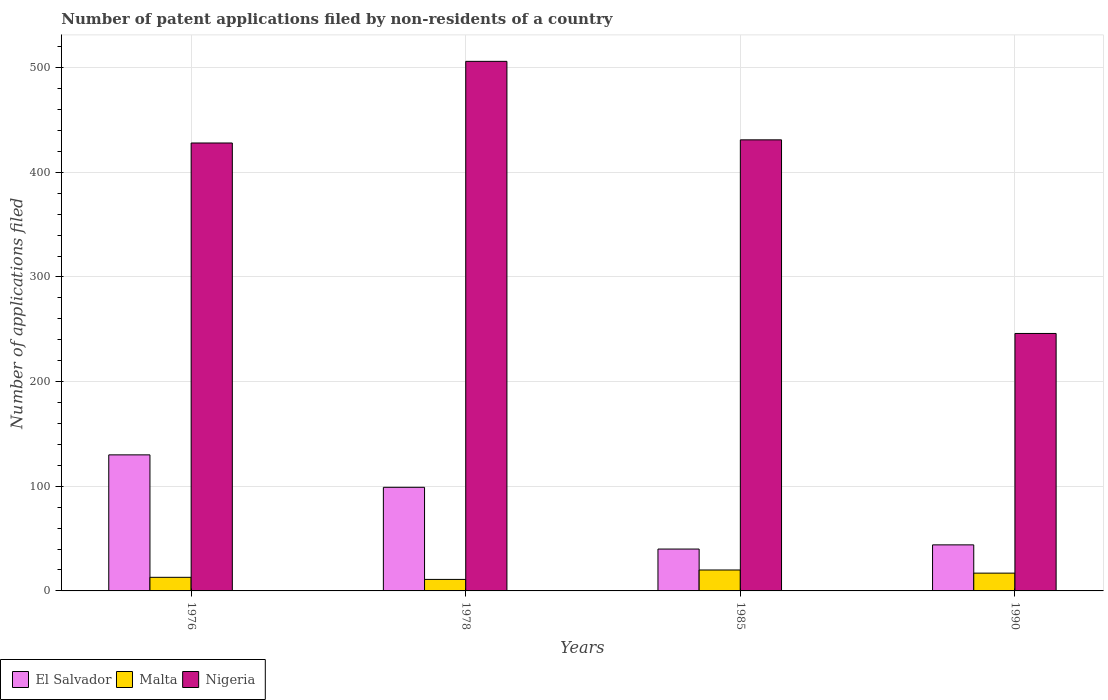How many different coloured bars are there?
Ensure brevity in your answer.  3. Are the number of bars per tick equal to the number of legend labels?
Your response must be concise. Yes. Are the number of bars on each tick of the X-axis equal?
Your response must be concise. Yes. What is the label of the 2nd group of bars from the left?
Your answer should be very brief. 1978. What is the number of applications filed in Nigeria in 1990?
Offer a very short reply. 246. Across all years, what is the maximum number of applications filed in Malta?
Your answer should be compact. 20. Across all years, what is the minimum number of applications filed in El Salvador?
Your answer should be compact. 40. In which year was the number of applications filed in El Salvador maximum?
Your response must be concise. 1976. In which year was the number of applications filed in Malta minimum?
Your response must be concise. 1978. What is the total number of applications filed in El Salvador in the graph?
Your response must be concise. 313. What is the difference between the number of applications filed in El Salvador in 1976 and the number of applications filed in Nigeria in 1978?
Provide a succinct answer. -376. What is the average number of applications filed in Nigeria per year?
Offer a very short reply. 402.75. In the year 1976, what is the difference between the number of applications filed in Nigeria and number of applications filed in Malta?
Give a very brief answer. 415. What is the ratio of the number of applications filed in El Salvador in 1976 to that in 1990?
Give a very brief answer. 2.95. Is the number of applications filed in El Salvador in 1976 less than that in 1990?
Offer a terse response. No. Is the difference between the number of applications filed in Nigeria in 1976 and 1985 greater than the difference between the number of applications filed in Malta in 1976 and 1985?
Offer a very short reply. Yes. What is the difference between the highest and the second highest number of applications filed in Nigeria?
Your answer should be very brief. 75. What is the difference between the highest and the lowest number of applications filed in Malta?
Keep it short and to the point. 9. Is the sum of the number of applications filed in Malta in 1978 and 1990 greater than the maximum number of applications filed in Nigeria across all years?
Provide a succinct answer. No. What does the 2nd bar from the left in 1976 represents?
Ensure brevity in your answer.  Malta. What does the 3rd bar from the right in 1985 represents?
Your answer should be compact. El Salvador. Is it the case that in every year, the sum of the number of applications filed in El Salvador and number of applications filed in Nigeria is greater than the number of applications filed in Malta?
Offer a terse response. Yes. How many years are there in the graph?
Provide a succinct answer. 4. What is the difference between two consecutive major ticks on the Y-axis?
Offer a very short reply. 100. Are the values on the major ticks of Y-axis written in scientific E-notation?
Offer a terse response. No. Does the graph contain any zero values?
Offer a terse response. No. Does the graph contain grids?
Your answer should be very brief. Yes. What is the title of the graph?
Offer a very short reply. Number of patent applications filed by non-residents of a country. What is the label or title of the Y-axis?
Your answer should be compact. Number of applications filed. What is the Number of applications filed of El Salvador in 1976?
Provide a short and direct response. 130. What is the Number of applications filed of Malta in 1976?
Your answer should be compact. 13. What is the Number of applications filed of Nigeria in 1976?
Offer a very short reply. 428. What is the Number of applications filed of El Salvador in 1978?
Keep it short and to the point. 99. What is the Number of applications filed of Nigeria in 1978?
Provide a succinct answer. 506. What is the Number of applications filed in Malta in 1985?
Offer a very short reply. 20. What is the Number of applications filed in Nigeria in 1985?
Provide a short and direct response. 431. What is the Number of applications filed in El Salvador in 1990?
Your answer should be compact. 44. What is the Number of applications filed in Nigeria in 1990?
Your answer should be very brief. 246. Across all years, what is the maximum Number of applications filed in El Salvador?
Provide a succinct answer. 130. Across all years, what is the maximum Number of applications filed of Nigeria?
Provide a succinct answer. 506. Across all years, what is the minimum Number of applications filed of El Salvador?
Keep it short and to the point. 40. Across all years, what is the minimum Number of applications filed of Nigeria?
Offer a terse response. 246. What is the total Number of applications filed in El Salvador in the graph?
Ensure brevity in your answer.  313. What is the total Number of applications filed in Nigeria in the graph?
Provide a short and direct response. 1611. What is the difference between the Number of applications filed in El Salvador in 1976 and that in 1978?
Keep it short and to the point. 31. What is the difference between the Number of applications filed in Malta in 1976 and that in 1978?
Offer a very short reply. 2. What is the difference between the Number of applications filed of Nigeria in 1976 and that in 1978?
Give a very brief answer. -78. What is the difference between the Number of applications filed of El Salvador in 1976 and that in 1985?
Your answer should be very brief. 90. What is the difference between the Number of applications filed in Malta in 1976 and that in 1985?
Your answer should be very brief. -7. What is the difference between the Number of applications filed in El Salvador in 1976 and that in 1990?
Give a very brief answer. 86. What is the difference between the Number of applications filed in Malta in 1976 and that in 1990?
Your response must be concise. -4. What is the difference between the Number of applications filed of Nigeria in 1976 and that in 1990?
Your answer should be compact. 182. What is the difference between the Number of applications filed of Malta in 1978 and that in 1985?
Ensure brevity in your answer.  -9. What is the difference between the Number of applications filed of El Salvador in 1978 and that in 1990?
Your answer should be very brief. 55. What is the difference between the Number of applications filed of Nigeria in 1978 and that in 1990?
Provide a succinct answer. 260. What is the difference between the Number of applications filed in Malta in 1985 and that in 1990?
Offer a very short reply. 3. What is the difference between the Number of applications filed of Nigeria in 1985 and that in 1990?
Your answer should be compact. 185. What is the difference between the Number of applications filed of El Salvador in 1976 and the Number of applications filed of Malta in 1978?
Offer a very short reply. 119. What is the difference between the Number of applications filed in El Salvador in 1976 and the Number of applications filed in Nigeria in 1978?
Offer a terse response. -376. What is the difference between the Number of applications filed in Malta in 1976 and the Number of applications filed in Nigeria in 1978?
Your answer should be very brief. -493. What is the difference between the Number of applications filed in El Salvador in 1976 and the Number of applications filed in Malta in 1985?
Your answer should be very brief. 110. What is the difference between the Number of applications filed in El Salvador in 1976 and the Number of applications filed in Nigeria in 1985?
Your answer should be very brief. -301. What is the difference between the Number of applications filed of Malta in 1976 and the Number of applications filed of Nigeria in 1985?
Your response must be concise. -418. What is the difference between the Number of applications filed in El Salvador in 1976 and the Number of applications filed in Malta in 1990?
Make the answer very short. 113. What is the difference between the Number of applications filed of El Salvador in 1976 and the Number of applications filed of Nigeria in 1990?
Give a very brief answer. -116. What is the difference between the Number of applications filed of Malta in 1976 and the Number of applications filed of Nigeria in 1990?
Make the answer very short. -233. What is the difference between the Number of applications filed of El Salvador in 1978 and the Number of applications filed of Malta in 1985?
Offer a very short reply. 79. What is the difference between the Number of applications filed of El Salvador in 1978 and the Number of applications filed of Nigeria in 1985?
Give a very brief answer. -332. What is the difference between the Number of applications filed of Malta in 1978 and the Number of applications filed of Nigeria in 1985?
Give a very brief answer. -420. What is the difference between the Number of applications filed in El Salvador in 1978 and the Number of applications filed in Nigeria in 1990?
Offer a terse response. -147. What is the difference between the Number of applications filed of Malta in 1978 and the Number of applications filed of Nigeria in 1990?
Offer a very short reply. -235. What is the difference between the Number of applications filed in El Salvador in 1985 and the Number of applications filed in Nigeria in 1990?
Provide a succinct answer. -206. What is the difference between the Number of applications filed in Malta in 1985 and the Number of applications filed in Nigeria in 1990?
Keep it short and to the point. -226. What is the average Number of applications filed of El Salvador per year?
Make the answer very short. 78.25. What is the average Number of applications filed of Malta per year?
Provide a short and direct response. 15.25. What is the average Number of applications filed in Nigeria per year?
Provide a succinct answer. 402.75. In the year 1976, what is the difference between the Number of applications filed in El Salvador and Number of applications filed in Malta?
Provide a short and direct response. 117. In the year 1976, what is the difference between the Number of applications filed of El Salvador and Number of applications filed of Nigeria?
Offer a terse response. -298. In the year 1976, what is the difference between the Number of applications filed in Malta and Number of applications filed in Nigeria?
Keep it short and to the point. -415. In the year 1978, what is the difference between the Number of applications filed in El Salvador and Number of applications filed in Malta?
Provide a short and direct response. 88. In the year 1978, what is the difference between the Number of applications filed of El Salvador and Number of applications filed of Nigeria?
Offer a very short reply. -407. In the year 1978, what is the difference between the Number of applications filed of Malta and Number of applications filed of Nigeria?
Your response must be concise. -495. In the year 1985, what is the difference between the Number of applications filed in El Salvador and Number of applications filed in Malta?
Give a very brief answer. 20. In the year 1985, what is the difference between the Number of applications filed in El Salvador and Number of applications filed in Nigeria?
Your response must be concise. -391. In the year 1985, what is the difference between the Number of applications filed of Malta and Number of applications filed of Nigeria?
Give a very brief answer. -411. In the year 1990, what is the difference between the Number of applications filed in El Salvador and Number of applications filed in Nigeria?
Offer a very short reply. -202. In the year 1990, what is the difference between the Number of applications filed of Malta and Number of applications filed of Nigeria?
Offer a very short reply. -229. What is the ratio of the Number of applications filed in El Salvador in 1976 to that in 1978?
Provide a short and direct response. 1.31. What is the ratio of the Number of applications filed of Malta in 1976 to that in 1978?
Provide a short and direct response. 1.18. What is the ratio of the Number of applications filed of Nigeria in 1976 to that in 1978?
Offer a very short reply. 0.85. What is the ratio of the Number of applications filed of Malta in 1976 to that in 1985?
Make the answer very short. 0.65. What is the ratio of the Number of applications filed of Nigeria in 1976 to that in 1985?
Provide a succinct answer. 0.99. What is the ratio of the Number of applications filed in El Salvador in 1976 to that in 1990?
Ensure brevity in your answer.  2.95. What is the ratio of the Number of applications filed in Malta in 1976 to that in 1990?
Provide a short and direct response. 0.76. What is the ratio of the Number of applications filed of Nigeria in 1976 to that in 1990?
Provide a short and direct response. 1.74. What is the ratio of the Number of applications filed of El Salvador in 1978 to that in 1985?
Make the answer very short. 2.48. What is the ratio of the Number of applications filed in Malta in 1978 to that in 1985?
Make the answer very short. 0.55. What is the ratio of the Number of applications filed of Nigeria in 1978 to that in 1985?
Ensure brevity in your answer.  1.17. What is the ratio of the Number of applications filed in El Salvador in 1978 to that in 1990?
Offer a very short reply. 2.25. What is the ratio of the Number of applications filed of Malta in 1978 to that in 1990?
Make the answer very short. 0.65. What is the ratio of the Number of applications filed of Nigeria in 1978 to that in 1990?
Provide a succinct answer. 2.06. What is the ratio of the Number of applications filed in El Salvador in 1985 to that in 1990?
Offer a very short reply. 0.91. What is the ratio of the Number of applications filed in Malta in 1985 to that in 1990?
Offer a very short reply. 1.18. What is the ratio of the Number of applications filed in Nigeria in 1985 to that in 1990?
Provide a succinct answer. 1.75. What is the difference between the highest and the second highest Number of applications filed in Malta?
Offer a terse response. 3. What is the difference between the highest and the lowest Number of applications filed in Nigeria?
Ensure brevity in your answer.  260. 